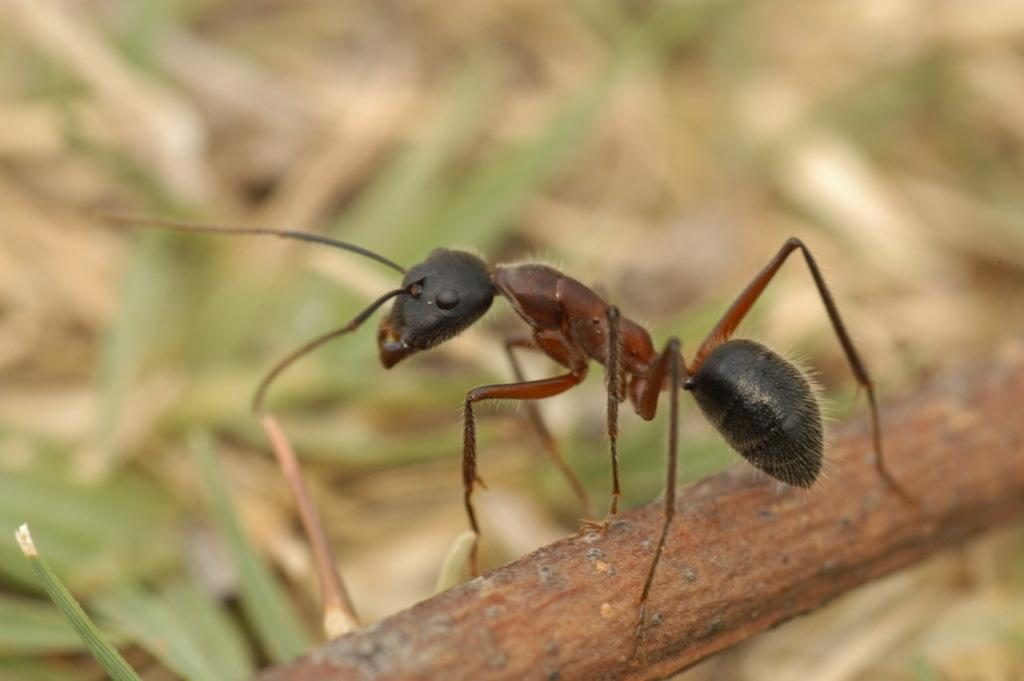What is the main subject of the image? There is an ant in the image. Where is the ant located in the image? The ant is on a stick. Can you describe the background of the image? The background of the image is blurred. What else can be seen in the image besides the ant? There are objects visible in the background of the image. What type of gold apparel is the ant wearing on its voyage in the image? There is no gold apparel or voyage present in the image; it features an ant on a stick with a blurred background. 